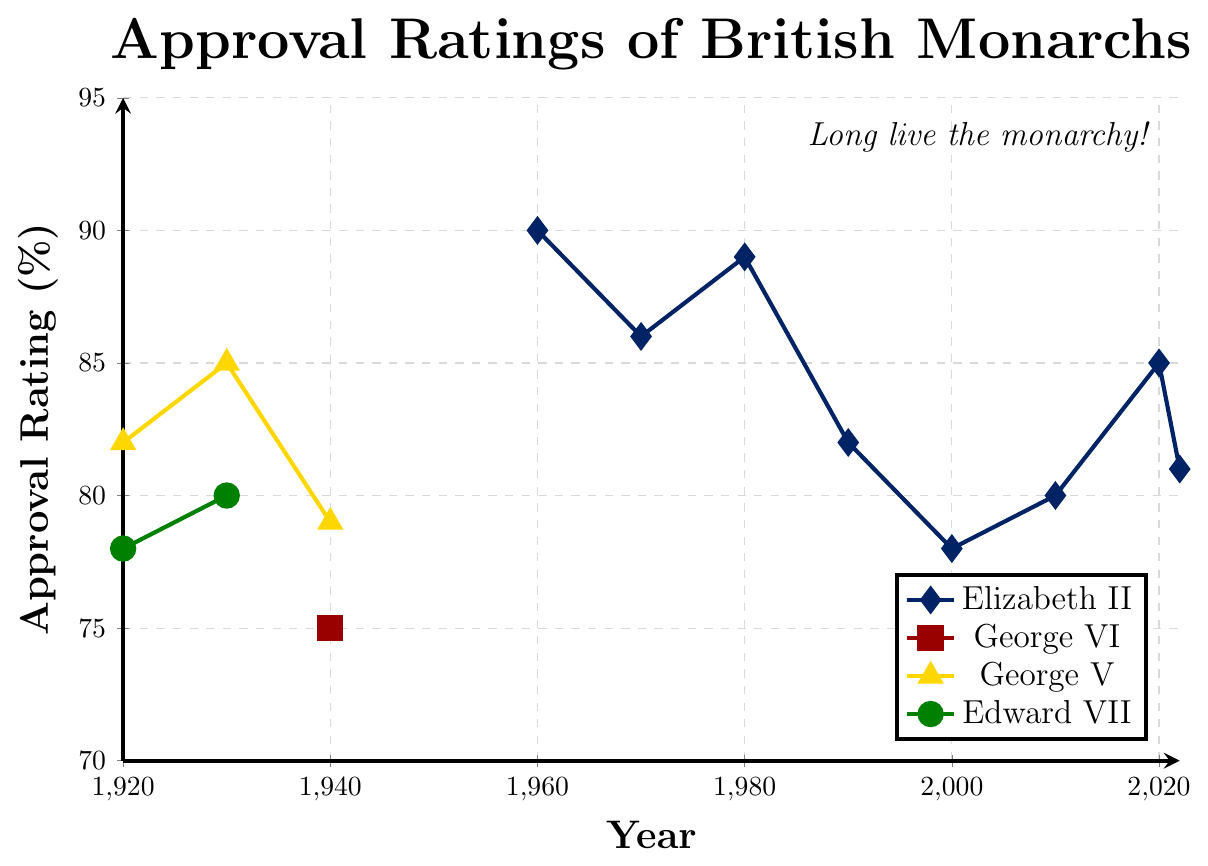What year shows the peak approval rating for Elizabeth II? Identify the highest approval rating for Elizabeth II from the plotted points on the chart, which is 90%, and note the corresponding year, 1960.
Answer: 1960 Find the average approval rating of George V during his reign. Identify the approval ratings of George V (82% in 1920, 85% in 1930, and 79% in 1940). Calculate the average: (82 + 85 + 79) / 3 = 82%.
Answer: 82% How much did Elizabeth II’s approval rating drop from 1960 to 2000? Note the approval ratings for Elizabeth II in 1960 and 2000 (90% and 78%, respectively). The drop is calculated as 90 - 78 = 12%.
Answer: 12% Which monarchs had approval ratings displayed using a diamond symbol? Identify the line plot using diamond markers, which corresponds to Elizabeth II, to whom approval ratings in the legend are matched with diamond symbols.
Answer: Elizabeth II Between 1930 and 1940, which monarch had the greatest decrease in approval ratings? Compare approval ratings for each monarch in 1930 and 1940. George V decreased from 85% in 1930 to 79% in 1940, resulting in a decrease of 6%. Edward VII's ratings end before 1940, so he is irrelevant for this period.
Answer: George V Which colour represents George VI on the chart? Refer to the visual representation. According to the legend, George VI is marked with a red square.
Answer: Red How many monarchs have approval ratings plotted around the year 1920? Check which monarchs are represented by data points around 1920. Observations for George V and Edward VII are provided for that year.
Answer: Two What is the overall trend of Elizabeth II’s approval rating from 1960 to 2022? Observe changes across the plotted points for Elizabeth II. It starts high in 1960 (90%), drops to a low of 78% in 2000, then slightly increases and stabilizes around 81%-85% until 2022. This can be summarized as an initial decline followed by a stabilization.
Answer: Decline followed by stabilization 